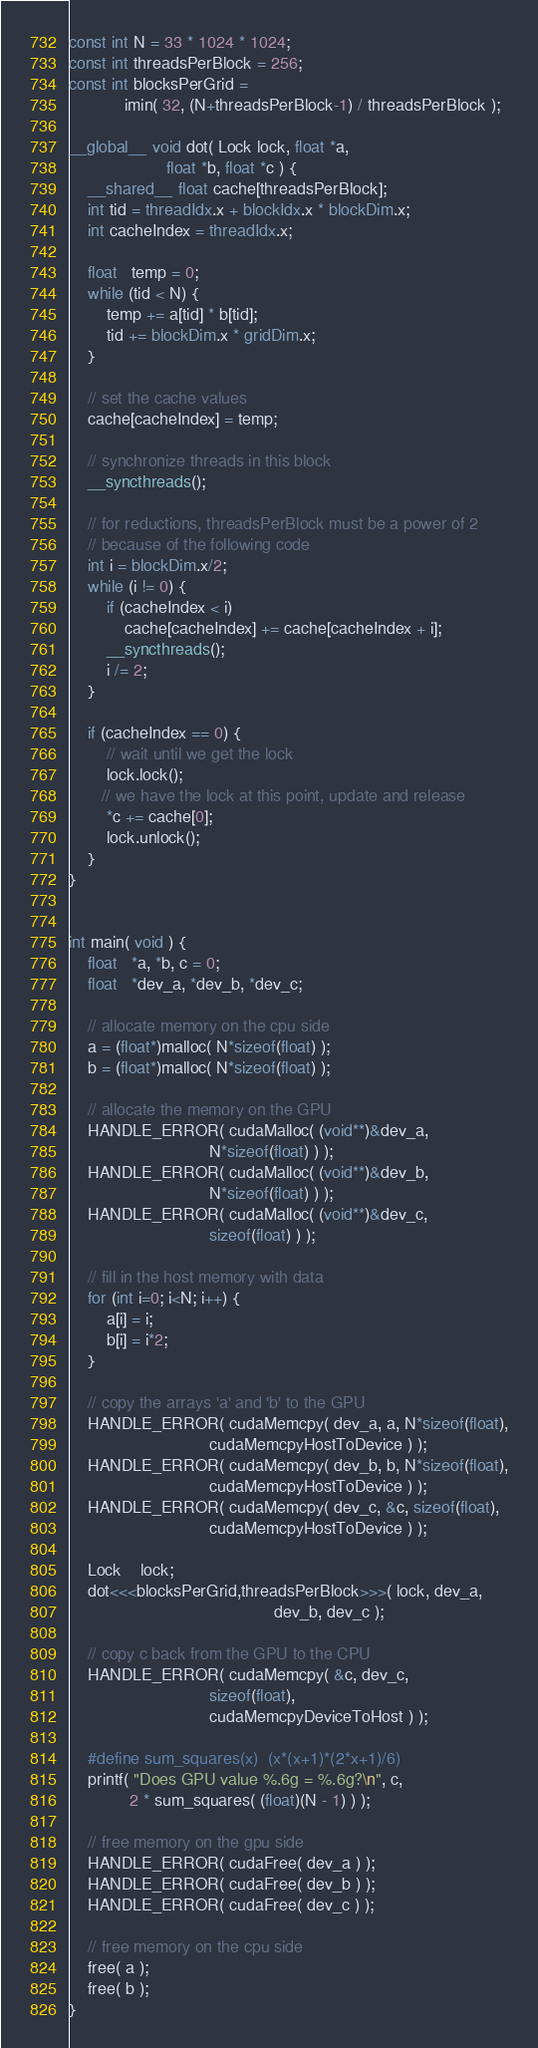Convert code to text. <code><loc_0><loc_0><loc_500><loc_500><_Cuda_>
const int N = 33 * 1024 * 1024;
const int threadsPerBlock = 256;
const int blocksPerGrid =
            imin( 32, (N+threadsPerBlock-1) / threadsPerBlock );

__global__ void dot( Lock lock, float *a,
                     float *b, float *c ) {
    __shared__ float cache[threadsPerBlock];
    int tid = threadIdx.x + blockIdx.x * blockDim.x;
    int cacheIndex = threadIdx.x;

    float   temp = 0;
    while (tid < N) {
        temp += a[tid] * b[tid];
        tid += blockDim.x * gridDim.x;
    }
    
    // set the cache values
    cache[cacheIndex] = temp;
    
    // synchronize threads in this block
    __syncthreads();

    // for reductions, threadsPerBlock must be a power of 2
    // because of the following code
    int i = blockDim.x/2;
    while (i != 0) {
        if (cacheIndex < i)
            cache[cacheIndex] += cache[cacheIndex + i];
        __syncthreads();
        i /= 2;
    }

    if (cacheIndex == 0) {
        // wait until we get the lock
        lock.lock();
       // we have the lock at this point, update and release
        *c += cache[0];
        lock.unlock();
    }
}


int main( void ) {
    float   *a, *b, c = 0;
    float   *dev_a, *dev_b, *dev_c;

    // allocate memory on the cpu side
    a = (float*)malloc( N*sizeof(float) );
    b = (float*)malloc( N*sizeof(float) );

    // allocate the memory on the GPU
    HANDLE_ERROR( cudaMalloc( (void**)&dev_a,
                              N*sizeof(float) ) );
    HANDLE_ERROR( cudaMalloc( (void**)&dev_b,
                              N*sizeof(float) ) );
    HANDLE_ERROR( cudaMalloc( (void**)&dev_c,
                              sizeof(float) ) );

    // fill in the host memory with data
    for (int i=0; i<N; i++) {
        a[i] = i;
        b[i] = i*2;
    }

    // copy the arrays 'a' and 'b' to the GPU
    HANDLE_ERROR( cudaMemcpy( dev_a, a, N*sizeof(float),
                              cudaMemcpyHostToDevice ) );
    HANDLE_ERROR( cudaMemcpy( dev_b, b, N*sizeof(float),
                              cudaMemcpyHostToDevice ) ); 
    HANDLE_ERROR( cudaMemcpy( dev_c, &c, sizeof(float),
                              cudaMemcpyHostToDevice ) ); 

    Lock    lock;
    dot<<<blocksPerGrid,threadsPerBlock>>>( lock, dev_a,
                                            dev_b, dev_c );

    // copy c back from the GPU to the CPU
    HANDLE_ERROR( cudaMemcpy( &c, dev_c,
                              sizeof(float),
                              cudaMemcpyDeviceToHost ) );

    #define sum_squares(x)  (x*(x+1)*(2*x+1)/6)
    printf( "Does GPU value %.6g = %.6g?\n", c,
             2 * sum_squares( (float)(N - 1) ) );

    // free memory on the gpu side
    HANDLE_ERROR( cudaFree( dev_a ) );
    HANDLE_ERROR( cudaFree( dev_b ) );
    HANDLE_ERROR( cudaFree( dev_c ) );

    // free memory on the cpu side
    free( a );
    free( b );
}
</code> 